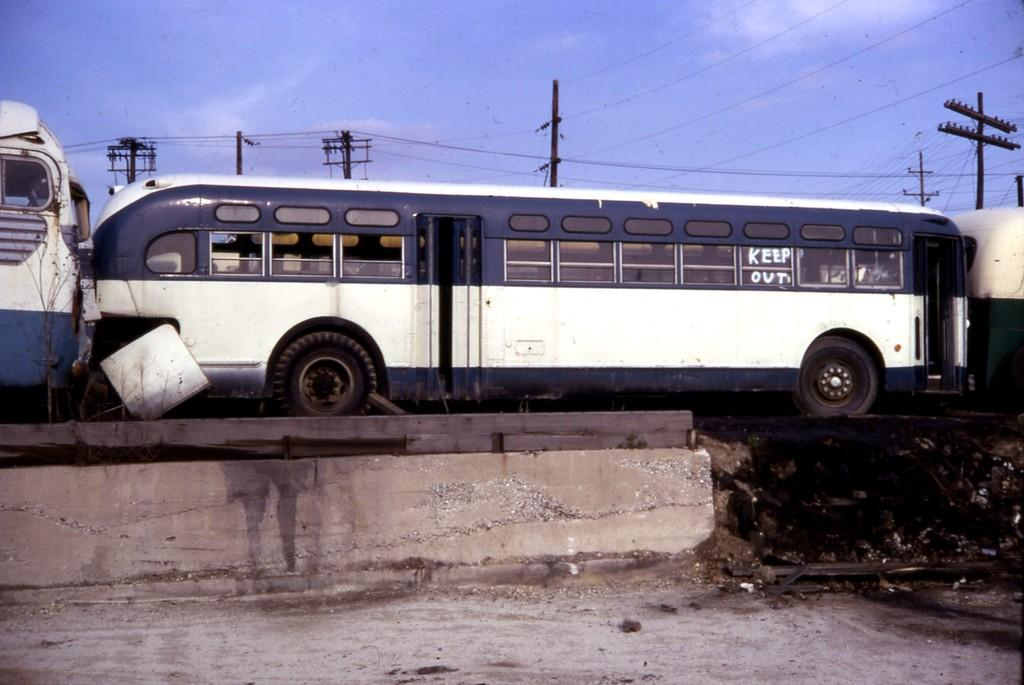What type of vehicles are in the image? There are buses in the image. What features do the buses have? The buses have doors and windows. What else can be seen in the image besides the buses? There are electric poles in the image. What are the electric poles connected to? The electric poles have wires. What is visible in the background of the image? The sky is visible in the image. What is the price of the finger shown in the image? There is no finger present in the image, so it is not possible to determine its price. 